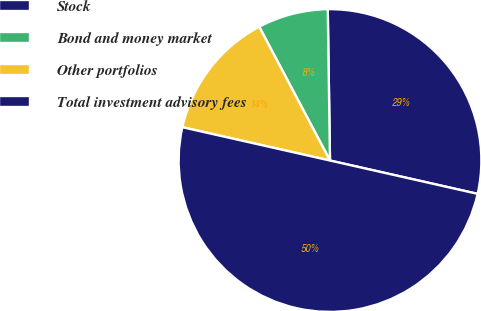Convert chart. <chart><loc_0><loc_0><loc_500><loc_500><pie_chart><fcel>Stock<fcel>Bond and money market<fcel>Other portfolios<fcel>Total investment advisory fees<nl><fcel>28.77%<fcel>7.51%<fcel>13.72%<fcel>50.0%<nl></chart> 